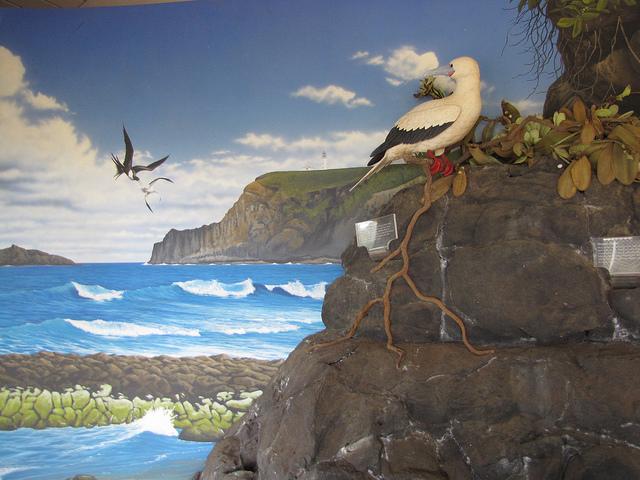Are there any people in the scene?
Answer briefly. No. Is this real or a picture?
Answer briefly. Picture. How many birds are there?
Be succinct. 3. 